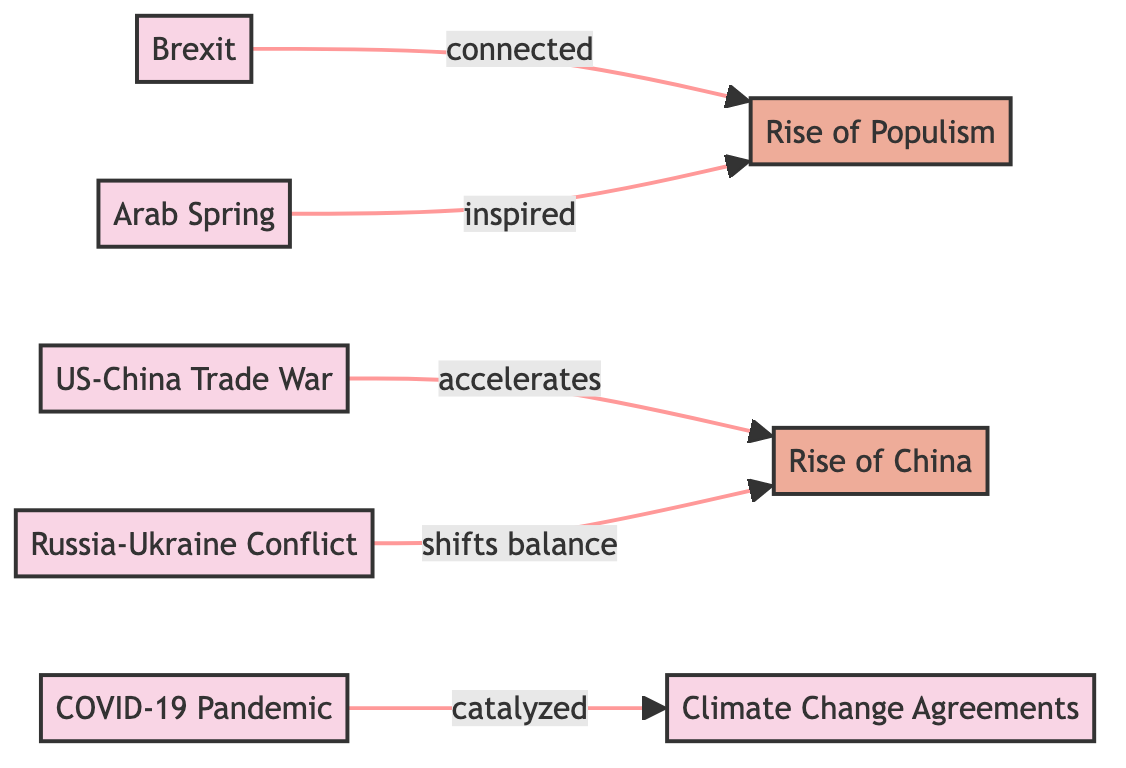What is the total number of events in the diagram? The diagram lists a total of 6 events: Brexit, US-China Trade War, Arab Spring, Russia-Ukraine Conflict, COVID-19 Pandemic, and Climate Change Agreements.
Answer: 6 Which event connects to the trend of Rise of Populism? The events directly connecting to the trend of Rise of Populism are Brexit and Arab Spring, as indicated by the directed edges leading to the trend.
Answer: Brexit, Arab Spring What relationship exists between the US-China Trade War and the Rise of China? The diagram specifies that the US-China Trade War "accelerates" the Rise of China, indicating a positive impact or enhancement in its influence.
Answer: accelerates How many edges are present in the diagram? By counting the relationships shown, there are a total of 5 edges demonstrated in the diagram connecting the events and trends.
Answer: 5 In what way does the COVID-19 Pandemic relate to Climate Change Agreements? The edge from COVID-19 Pandemic to Climate Change Agreements is labeled "catalyzed," indicating that the pandemic had a triggering effect on the discussions or agreements related to climate change.
Answer: catalyzed Which event is stated to have inspired the Rise of Populism? The Arab Spring is indicated as the event that inspired the trend of Rise of Populism in the directed graph.
Answer: Arab Spring What event shifts the balance towards the Rise of China? The Russia-Ukraine Conflict is noted as having the effect of shifting the balance towards the Rise of China, as marked by the connecting edge.
Answer: Russia-Ukraine Conflict How many trends are represented in the diagram? There are 2 trends represented in the diagram: Rise of China and Rise of Populism.
Answer: 2 What type of connections are shown between events and trends in the diagram? The connections in the diagram are directed edges, showing the influence or relationship between events and trends, indicating cause-effect or enhancement relationships.
Answer: directed edges 